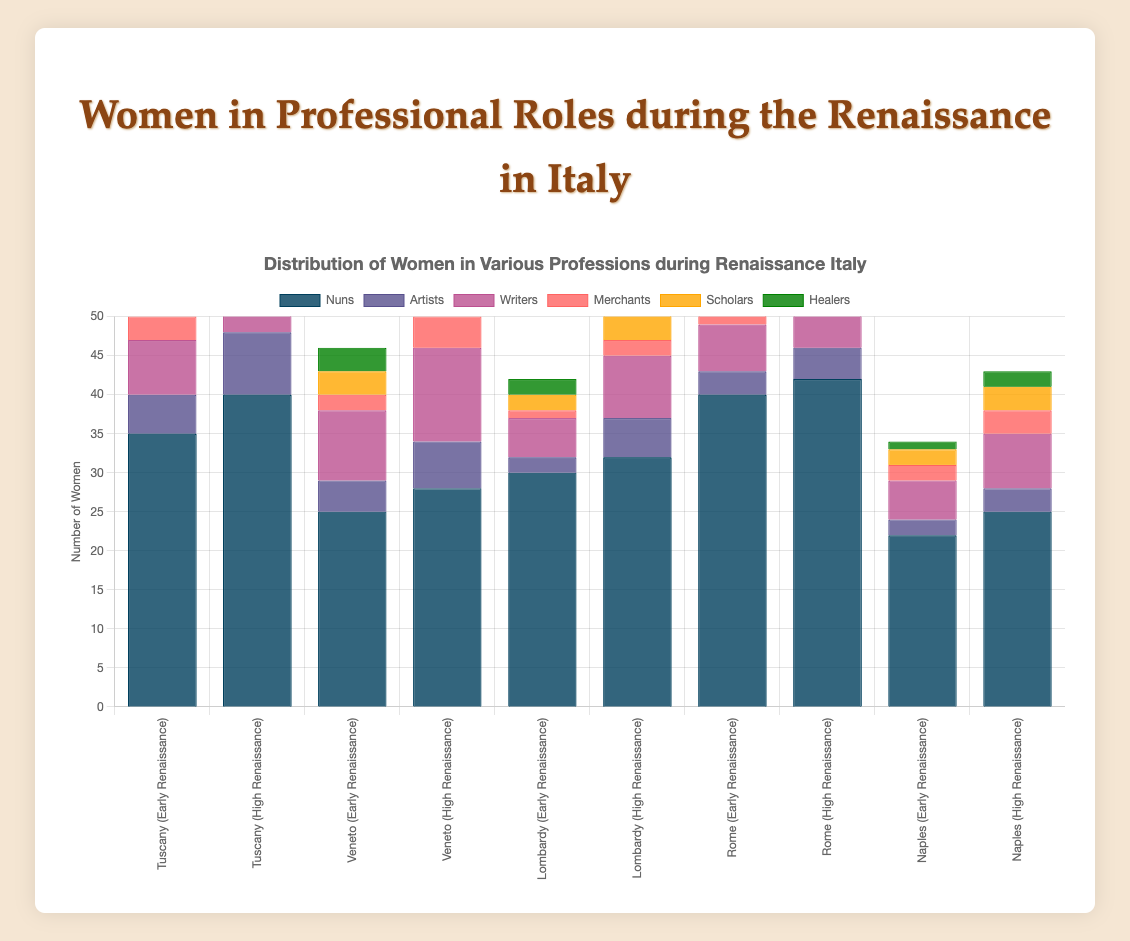What is the total number of nuns across all regions during the High Renaissance? To find the total number of nuns during the High Renaissance, sum the number of nuns in each region: Tuscany (40), Veneto (28), Lombardy (32), Rome (42), Naples (25). The calculation is 40 + 28 + 32 + 42 + 25 = 167
Answer: 167 Which region had the highest increase in the number of writers from the Early Renaissance to the High Renaissance? Calculate the increase in writers for each region by subtracting the number of writers in the Early Renaissance from those in the High Renaissance: Tuscany (10 - 7 = 3), Veneto (12 - 9 = 3), Lombardy (8 - 5 = 3), Rome (9 - 6 = 3), Naples (7 - 5 = 2). Tuscany, Veneto, Lombardy, and Rome all had the highest increase of 3 writers each.
Answer: Tuscany, Veneto, Lombardy, and Rome Which profession had the lowest total number of women across all regions in the Early Renaissance? Sum the number of women in each profession across all regions during the Early Renaissance: Nuns (35 + 25 + 30 + 40 + 22 = 152), Artists (5 + 4 + 2 + 3 + 2 = 16), Writers (7 + 9 + 5 + 6 + 5 = 32), Merchants (3 + 2 + 1 + 2 + 2 = 10), Scholars (2 + 3 + 2 + 4 + 2 = 13), Healers (4 + 3 + 2 + 2 + 1 = 12). The lowest total is for artists with 16 women.
Answer: Artists How many more scholars were there in Veneto during the High Renaissance compared to the Early Renaissance? Subtract the number of scholars in Veneto in the Early Renaissance from those in the High Renaissance: 6 - 3 = 3
Answer: 3 Which region had the most women in merchants during the High Renaissance? Compare the number of merchants in each region during the High Renaissance: Tuscany (5), Veneto (4), Lombardy (2), Rome (4), Naples (3). The region with the most women in merchants is Tuscany with 5.
Answer: Tuscany Across all regions during the Early Renaissance, which profession had the second highest number of women? Sum the number of women in each profession across all regions during the Early Renaissance: Nuns (152), Artists (16), Writers (32), Merchants (10), Scholars (13), Healers (12). The second highest number of women is in writers with 32.
Answer: Writers How did the number of healers in Rome change from the Early Renaissance to the High Renaissance? Compare the number of healers in Rome from the Early Renaissance (2) to the High Renaissance (4). The number increased by 2.
Answer: Increased by 2 Which region had the fewest women in total during the High Renaissance? Sum the total number of women in each profession for each region during the High Renaissance: Tuscany (74), Veneto (61), Lombardy (55), Rome (69), Naples (40). The region with the fewest women is Naples with 40.
Answer: Naples 